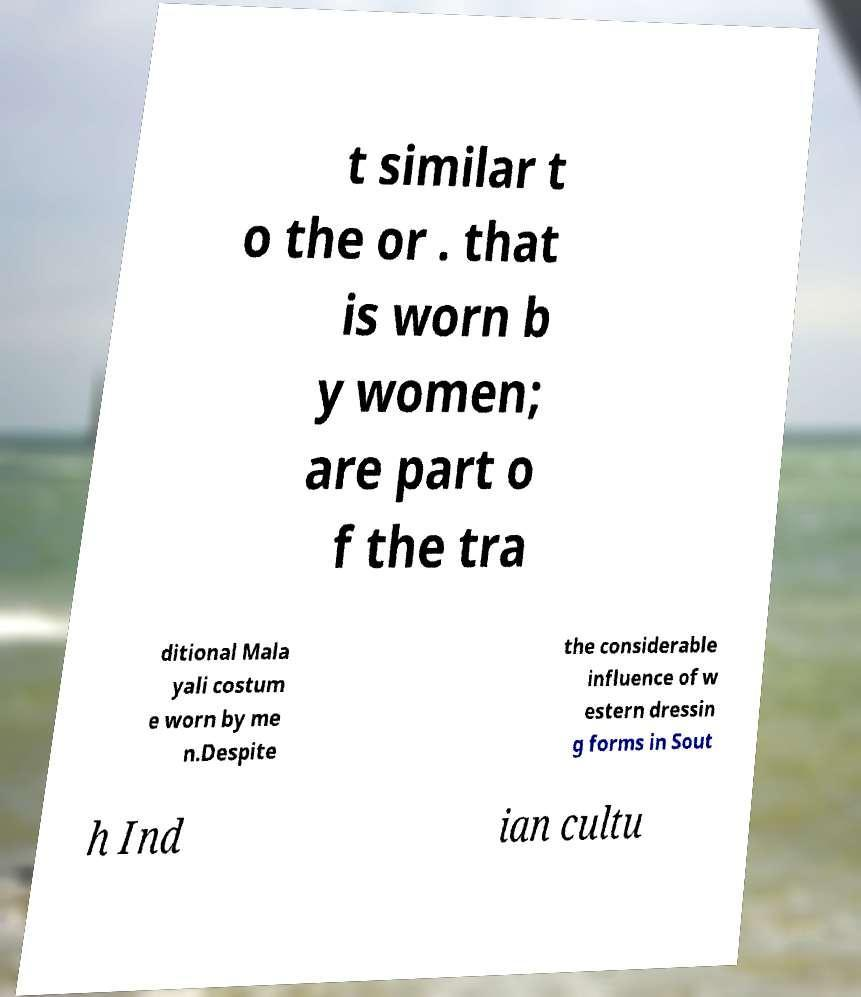Can you read and provide the text displayed in the image?This photo seems to have some interesting text. Can you extract and type it out for me? t similar t o the or . that is worn b y women; are part o f the tra ditional Mala yali costum e worn by me n.Despite the considerable influence of w estern dressin g forms in Sout h Ind ian cultu 